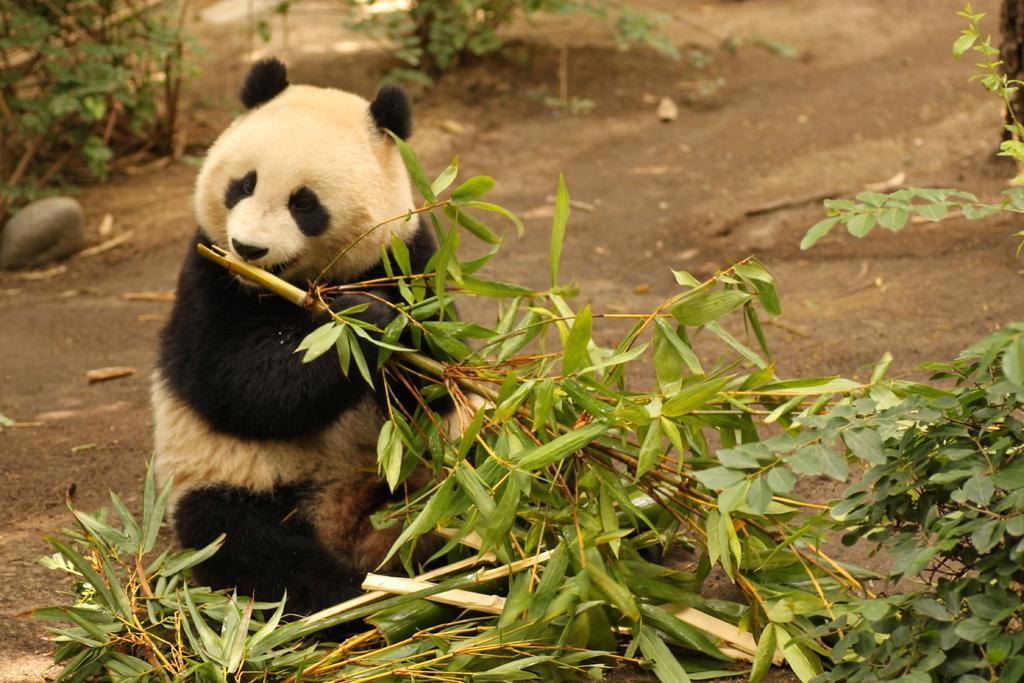Please provide a concise description of this image. In the image we can see a panda, white and black in color. Here we can see leaves and stone. 